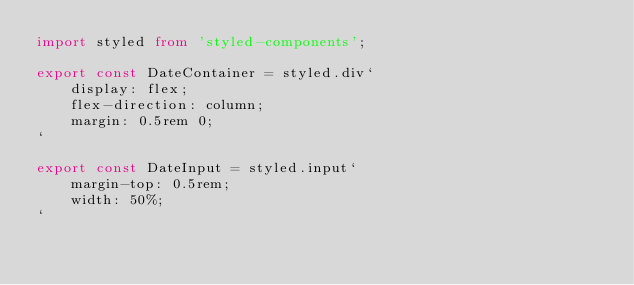<code> <loc_0><loc_0><loc_500><loc_500><_TypeScript_>import styled from 'styled-components';

export const DateContainer = styled.div`
    display: flex;
    flex-direction: column;
    margin: 0.5rem 0;
`

export const DateInput = styled.input`
    margin-top: 0.5rem;
    width: 50%;
`</code> 